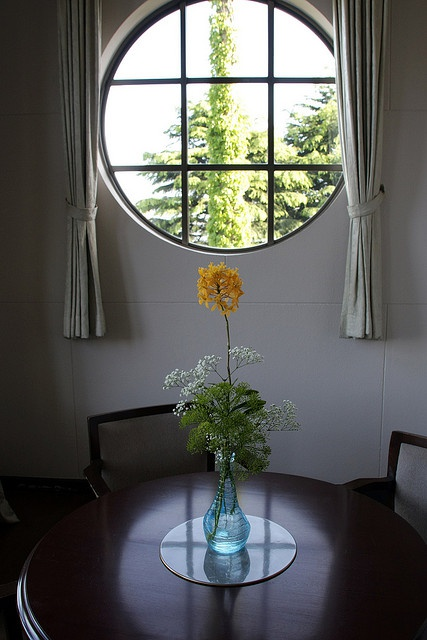Describe the objects in this image and their specific colors. I can see dining table in black, gray, and darkgray tones, chair in black and gray tones, vase in black, gray, and blue tones, and chair in black, gray, and darkgray tones in this image. 